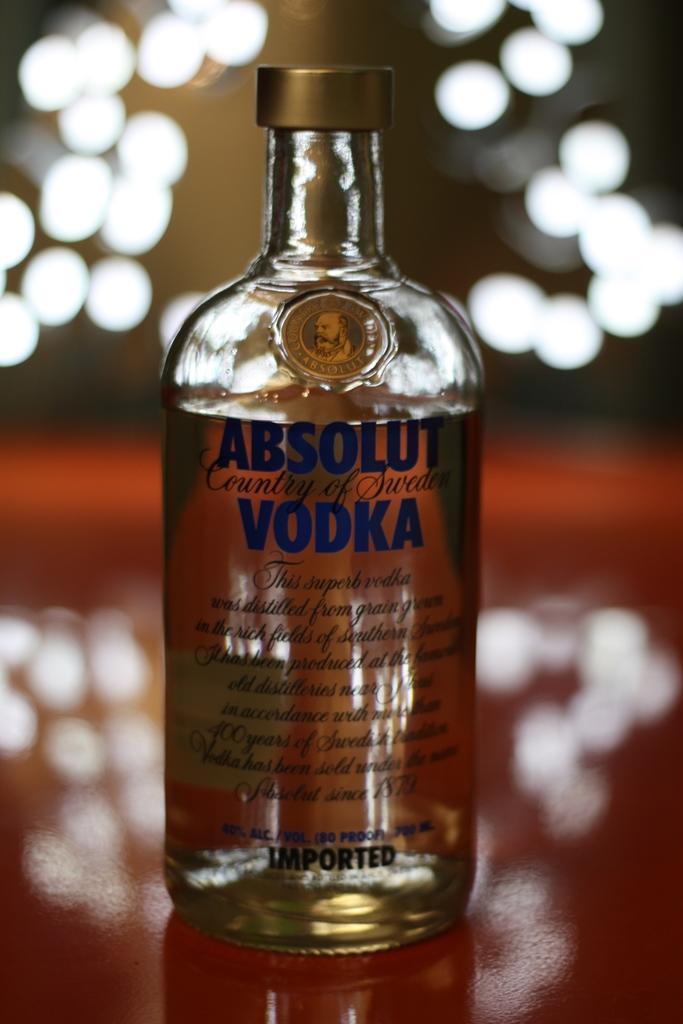Can you describe this image briefly? In this image there is a vodka bottle on it it is written absolut vodka. 